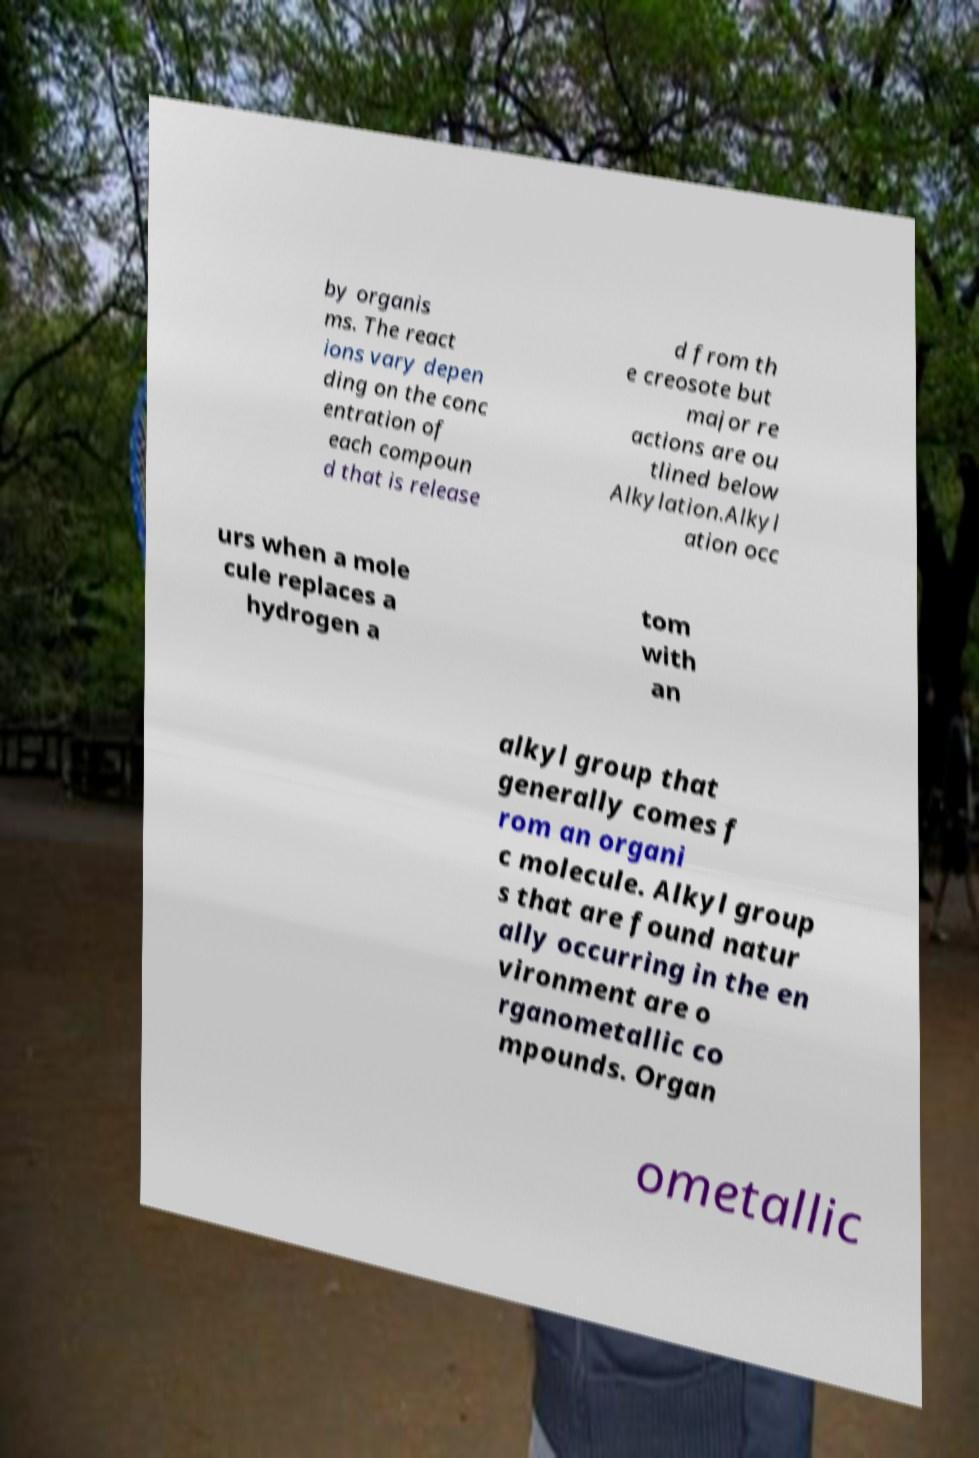Could you assist in decoding the text presented in this image and type it out clearly? by organis ms. The react ions vary depen ding on the conc entration of each compoun d that is release d from th e creosote but major re actions are ou tlined below Alkylation.Alkyl ation occ urs when a mole cule replaces a hydrogen a tom with an alkyl group that generally comes f rom an organi c molecule. Alkyl group s that are found natur ally occurring in the en vironment are o rganometallic co mpounds. Organ ometallic 